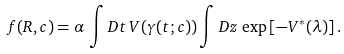Convert formula to latex. <formula><loc_0><loc_0><loc_500><loc_500>f ( R , c ) = \alpha \, \int D t \, V ( \gamma ( t ; c ) ) \int D z \, \exp \left [ - V ^ { * } ( \lambda ) \right ] .</formula> 